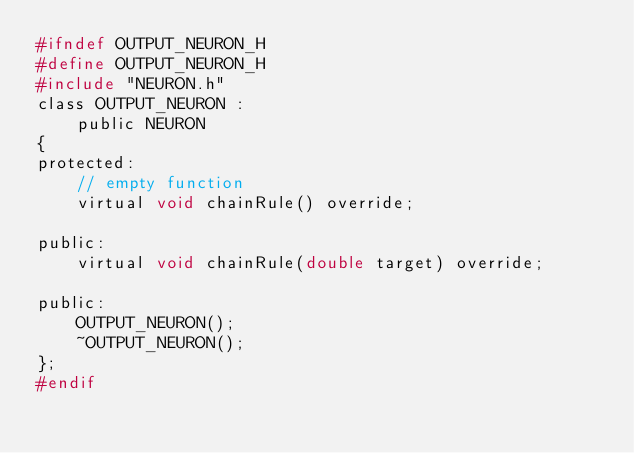Convert code to text. <code><loc_0><loc_0><loc_500><loc_500><_C_>#ifndef OUTPUT_NEURON_H
#define OUTPUT_NEURON_H
#include "NEURON.h"
class OUTPUT_NEURON :
	public NEURON
{
protected:
	// empty function
	virtual void chainRule() override;

public:
	virtual void chainRule(double target) override;

public:
	OUTPUT_NEURON();
	~OUTPUT_NEURON();
};
#endif

</code> 